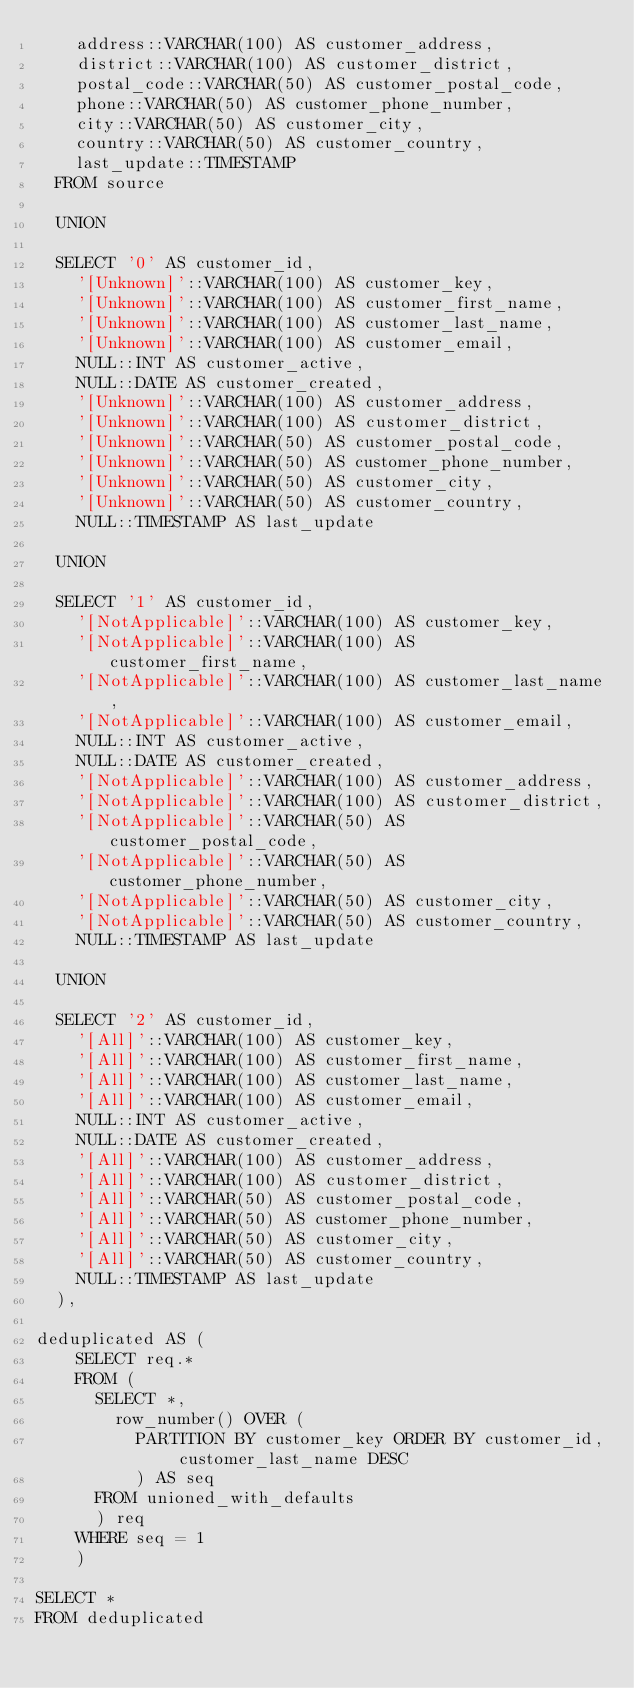Convert code to text. <code><loc_0><loc_0><loc_500><loc_500><_SQL_>		address::VARCHAR(100) AS customer_address,
		district::VARCHAR(100) AS customer_district,
		postal_code::VARCHAR(50) AS customer_postal_code,
		phone::VARCHAR(50) AS customer_phone_number,
		city::VARCHAR(50) AS customer_city,
		country::VARCHAR(50) AS customer_country,
		last_update::TIMESTAMP
	FROM source
	
	UNION
	
	SELECT '0' AS customer_id,
		'[Unknown]'::VARCHAR(100) AS customer_key,
		'[Unknown]'::VARCHAR(100) AS customer_first_name,
		'[Unknown]'::VARCHAR(100) AS customer_last_name,
		'[Unknown]'::VARCHAR(100) AS customer_email,
		NULL::INT AS customer_active,
		NULL::DATE AS customer_created,
		'[Unknown]'::VARCHAR(100) AS customer_address,
		'[Unknown]'::VARCHAR(100) AS customer_district,
		'[Unknown]'::VARCHAR(50) AS customer_postal_code,
		'[Unknown]'::VARCHAR(50) AS customer_phone_number,
		'[Unknown]'::VARCHAR(50) AS customer_city,
		'[Unknown]'::VARCHAR(50) AS customer_country,
		NULL::TIMESTAMP AS last_update
	
	UNION
	
	SELECT '1' AS customer_id,
		'[NotApplicable]'::VARCHAR(100) AS customer_key,
		'[NotApplicable]'::VARCHAR(100) AS customer_first_name,
		'[NotApplicable]'::VARCHAR(100) AS customer_last_name,
		'[NotApplicable]'::VARCHAR(100) AS customer_email,
		NULL::INT AS customer_active,
		NULL::DATE AS customer_created,
		'[NotApplicable]'::VARCHAR(100) AS customer_address,
		'[NotApplicable]'::VARCHAR(100) AS customer_district,
		'[NotApplicable]'::VARCHAR(50) AS customer_postal_code,
		'[NotApplicable]'::VARCHAR(50) AS customer_phone_number,
		'[NotApplicable]'::VARCHAR(50) AS customer_city,
		'[NotApplicable]'::VARCHAR(50) AS customer_country,
		NULL::TIMESTAMP AS last_update
	
	UNION
	
	SELECT '2' AS customer_id,
		'[All]'::VARCHAR(100) AS customer_key,
		'[All]'::VARCHAR(100) AS customer_first_name,
		'[All]'::VARCHAR(100) AS customer_last_name,
		'[All]'::VARCHAR(100) AS customer_email,
		NULL::INT AS customer_active,
		NULL::DATE AS customer_created,
		'[All]'::VARCHAR(100) AS customer_address,
		'[All]'::VARCHAR(100) AS customer_district,
		'[All]'::VARCHAR(50) AS customer_postal_code,
		'[All]'::VARCHAR(50) AS customer_phone_number,
		'[All]'::VARCHAR(50) AS customer_city,
		'[All]'::VARCHAR(50) AS customer_country,
		NULL::TIMESTAMP AS last_update
	),

deduplicated AS (
		SELECT req.*
		FROM (
			SELECT *,
				row_number() OVER (
					PARTITION BY customer_key ORDER BY customer_id, customer_last_name DESC
					) AS seq
			FROM unioned_with_defaults
			) req
		WHERE seq = 1
		)

SELECT *
FROM deduplicated
</code> 